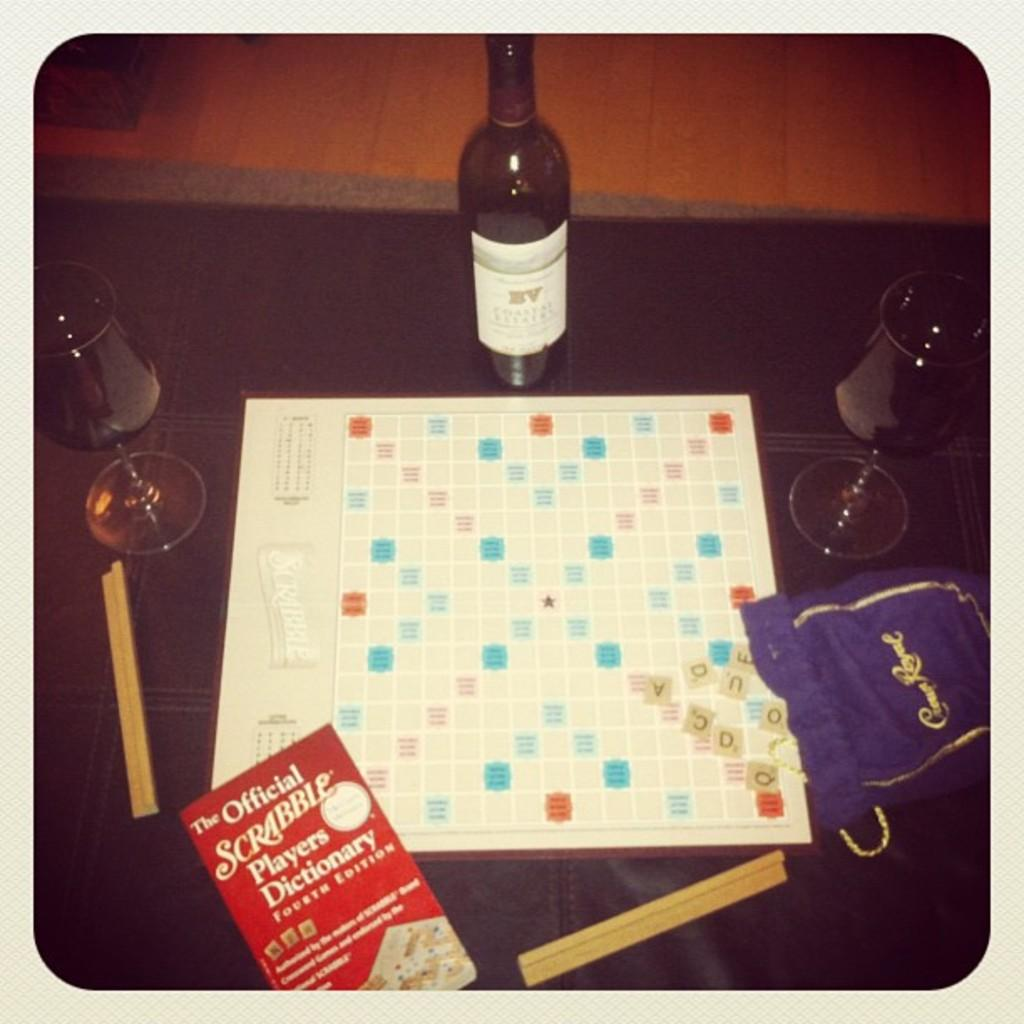What type of container is present in the image? There is a bottle in the image. What type of glass is present in the image? There is a wine glass in the image. What small objects can be seen in the image? There are small sticks in the image. What type of reading material is present in the image? There is a book in the image. What type of game or activity is present in the image? There is a play board in the image. What type of work is being done in the image? There is no indication of work being done in the image. The objects present are a bottle, wine glass, small sticks, book, and play board, which do not suggest any work-related activity. 